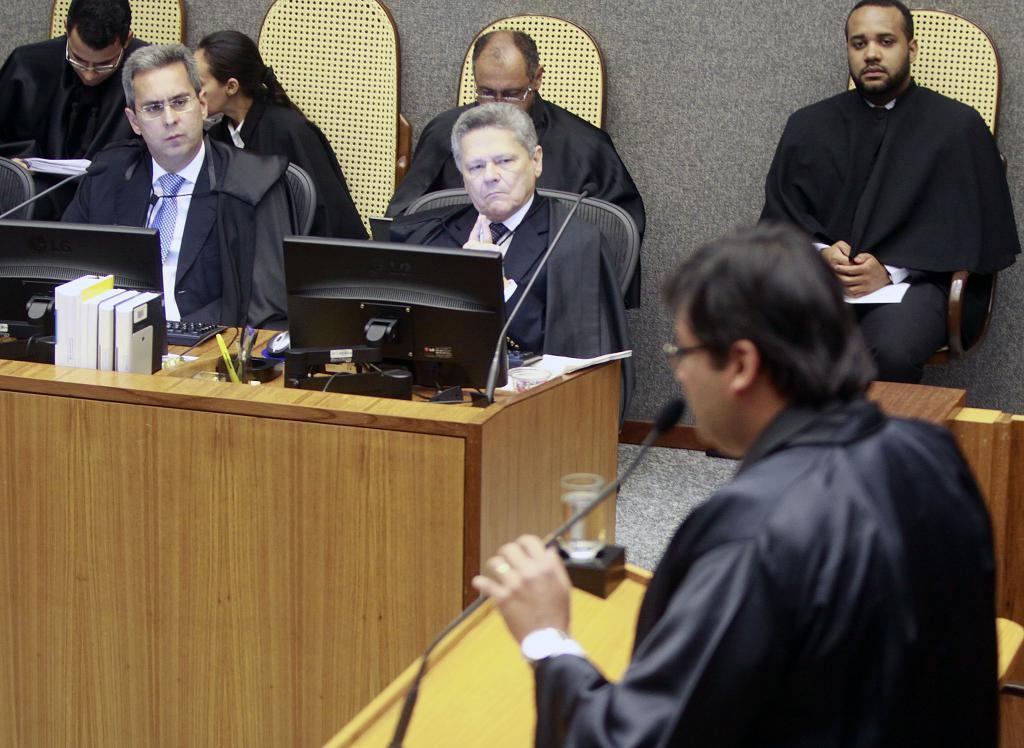Could you give a brief overview of what you see in this image? In the image there are some tablets and desktops and books and pens and papers and mouse and keyboards and microphones. Behind them there are some chairs and few people are sitting and watching. Behind them there is a wall. In the bottom right corner of the image a man is standing and holding a microphone. 